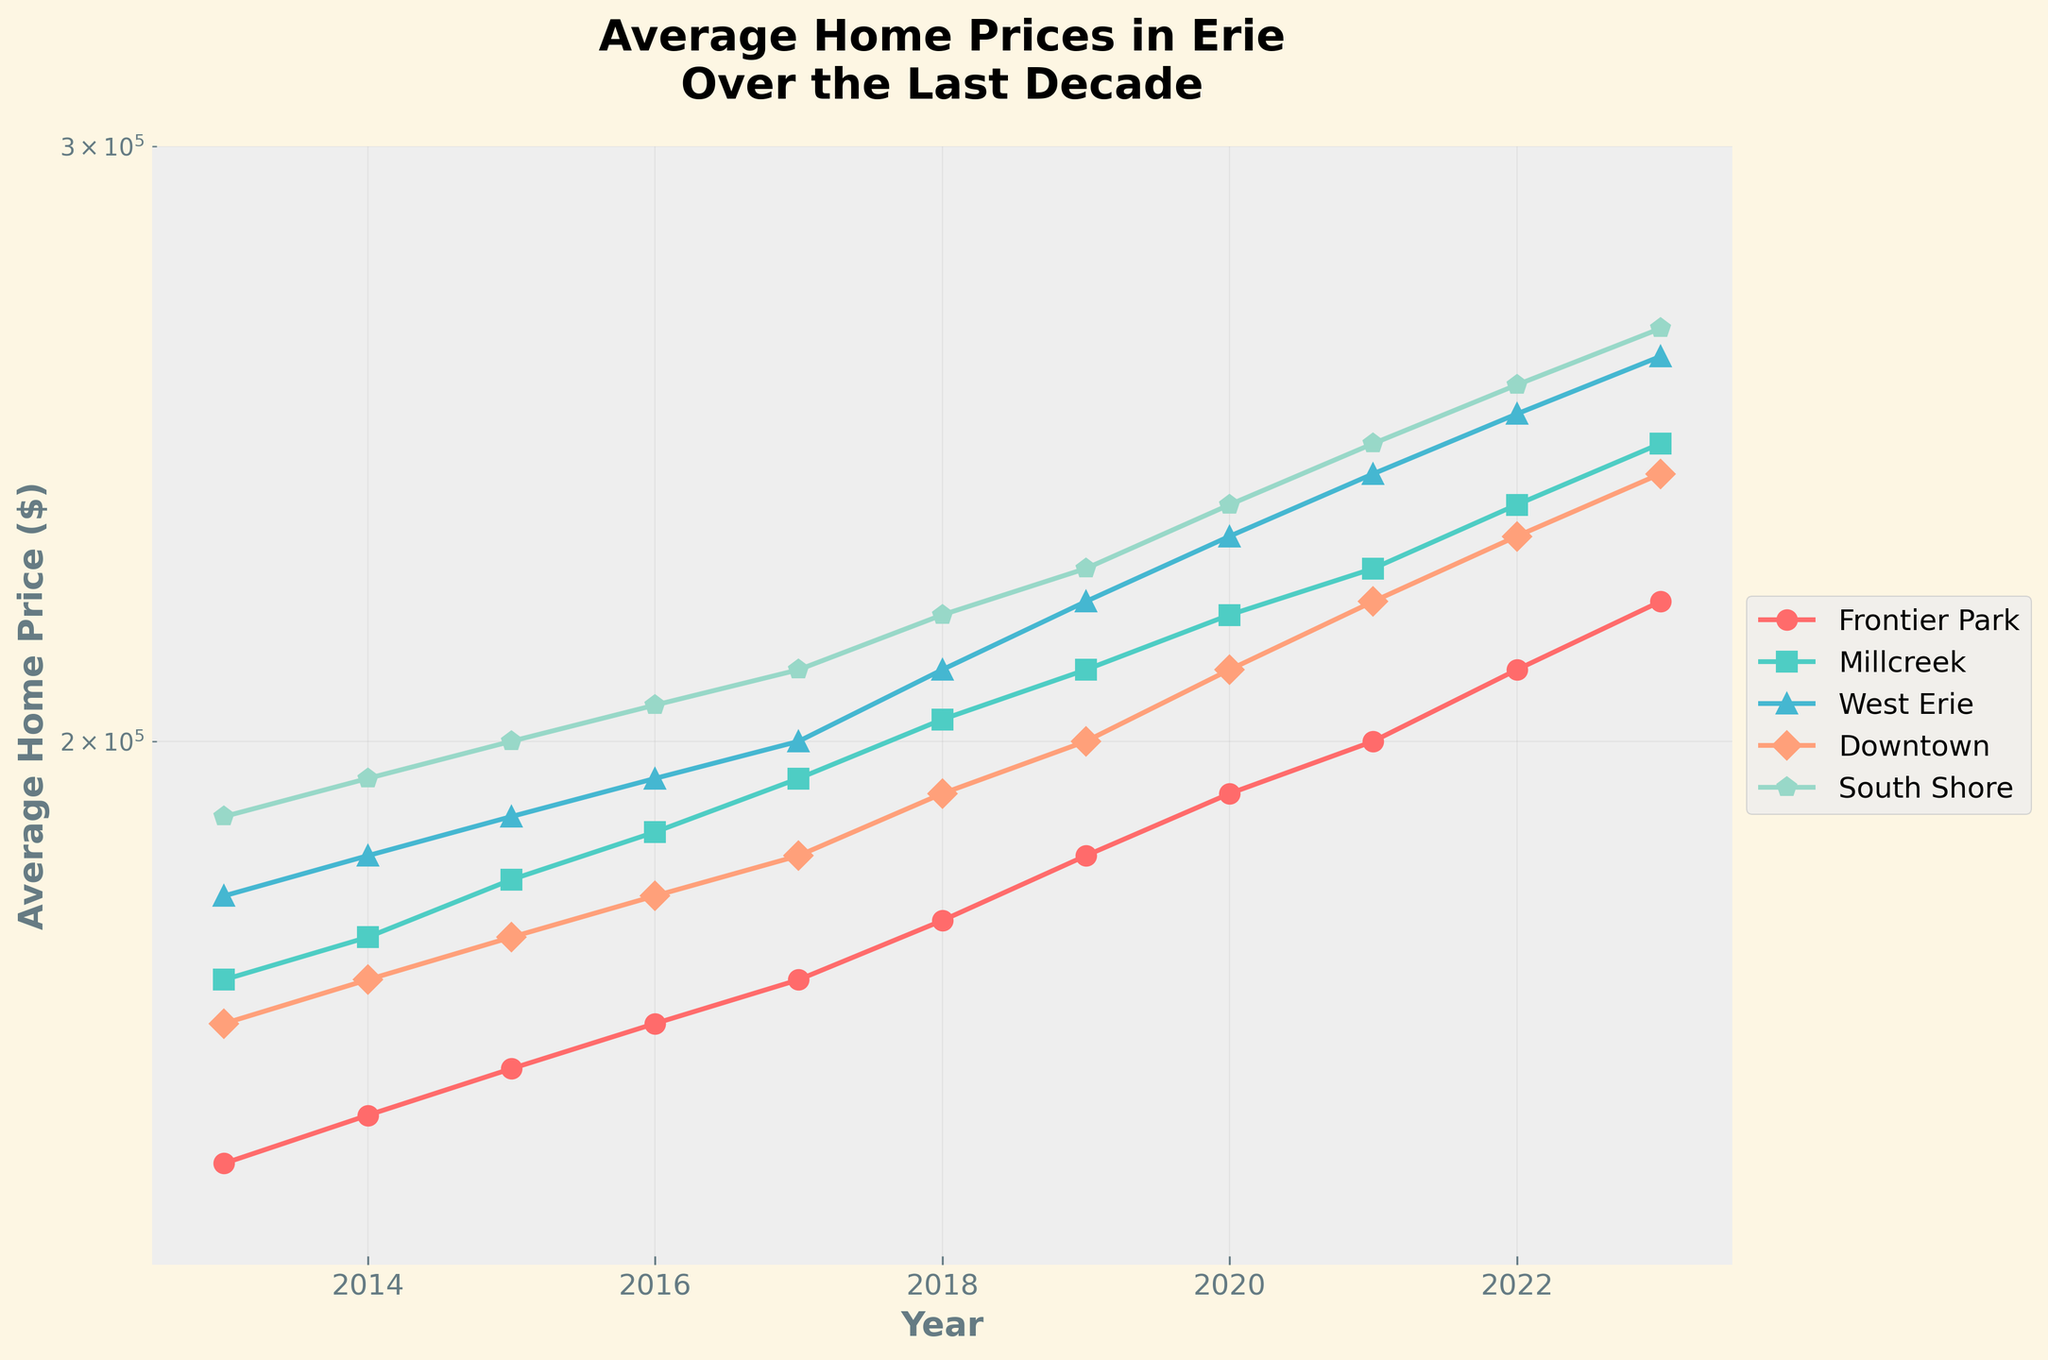What's the title of the plot? The title is centered at the top of the plot, above all lines and labels.
Answer: Average Home Prices in Erie Over the Last Decade What colors are used to represent the different neighborhoods? The colors of the lines are visible and distinguishable for each neighborhood in the legend on the right. The colors are red, teal, light blue, salmon, and light green.
Answer: Red (Frontier Park), Teal (Millcreek), Light Blue (West Erie), Salmon (Downtown), Light Green (South Shore) What is the average home price in Downtown in 2023? Locate the line representing Downtown (salmon color) and find its value at the year marker for 2023.
Answer: $240,000 Which neighborhood had the lowest average home price in 2013? Check the starting points of the lines in 2013 and identify which one is the lowest on the y-axis.
Answer: Frontier Park How much did the average home price in South Shore increase from 2013 to 2023? Subtract the value for South Shore in 2013 from its value in 2023. The values can be found by following the light green line.
Answer: $75,000 Which neighborhood shows the largest overall increase in average home prices over the last decade? Determine the initial (2013) and final (2023) average home prices for each neighborhood by comparing the start and end values of each line. Calculate the increase and identify the largest one.
Answer: South Shore By how much did the average home price in Millcreek change from 2017 to 2018? Compare the values of Millcreek for the years 2017 and 2018 using the teal line and take their difference.
Answer: $8,000 Which neighborhood consistently had the highest average home prices over the years? Examine the lines representing each neighborhood across all years and note which one is positioned highest on the y-axis throughout the timeline.
Answer: South Shore What is the shape of the curve for West Erie between 2013 and 2023? Observe the pattern and general trajectory of the light blue line from 2013 to 2023.
Answer: Upward-sloping How do the trends in average home prices for Frontier Park and Millcreek compare over the last decade? Compare the red and teal lines over the entire decade to note similarities and differences in their trajectory.
Answer: Both show consistent upward trends, with Millcreek having higher end values than Frontier Park 